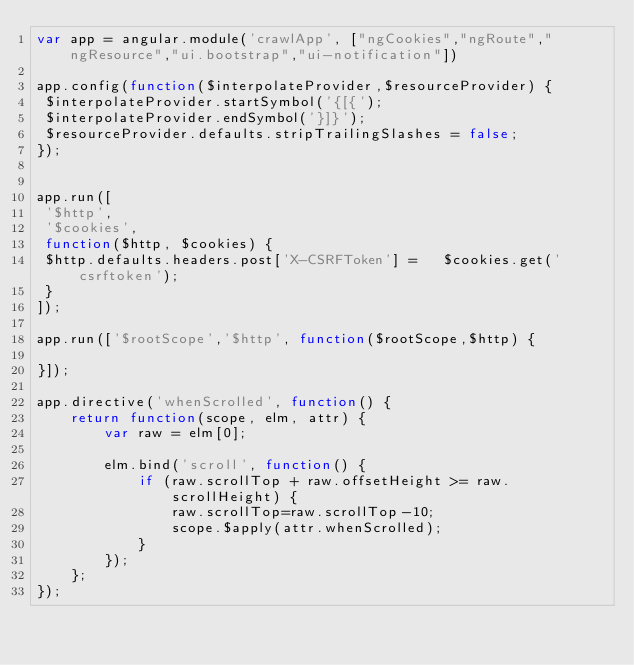Convert code to text. <code><loc_0><loc_0><loc_500><loc_500><_JavaScript_>var app = angular.module('crawlApp', ["ngCookies","ngRoute","ngResource","ui.bootstrap","ui-notification"])

app.config(function($interpolateProvider,$resourceProvider) {
 $interpolateProvider.startSymbol('{[{');
 $interpolateProvider.endSymbol('}]}');
 $resourceProvider.defaults.stripTrailingSlashes = false;
});


app.run([
 '$http',
 '$cookies',
 function($http, $cookies) {
 $http.defaults.headers.post['X-CSRFToken'] =   $cookies.get('csrftoken');
 }
]);

app.run(['$rootScope','$http', function($rootScope,$http) {
  
}]);

app.directive('whenScrolled', function() {
    return function(scope, elm, attr) {
        var raw = elm[0];
        
        elm.bind('scroll', function() {
            if (raw.scrollTop + raw.offsetHeight >= raw.scrollHeight) {
                raw.scrollTop=raw.scrollTop-10;
                scope.$apply(attr.whenScrolled);
            }
        });
    };
});</code> 